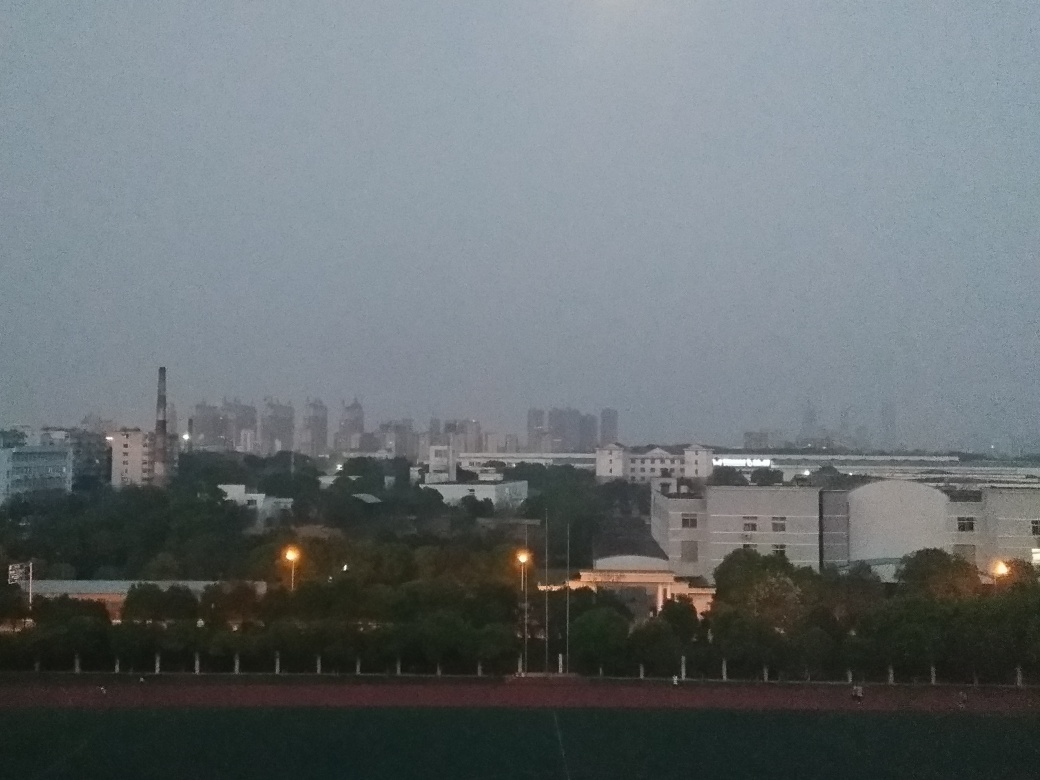Is the weather clear or cloudy in this image? The sky appears overcast with cloudy conditions, which diffuses the light and creates a flat lighting scenario without strong shadows or highlights. What can we infer about the location of this scene? Considering the mix of industrial and high-density urban structures, it's likely this scene is located in the outskirts of a major city, where industrial areas often transition to residential zones. 